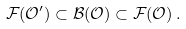<formula> <loc_0><loc_0><loc_500><loc_500>\mathcal { F } ( \mathcal { O } ^ { \prime } ) \subset \mathcal { B } ( \mathcal { O } ) \subset \mathcal { F } ( \mathcal { O } ) \, .</formula> 